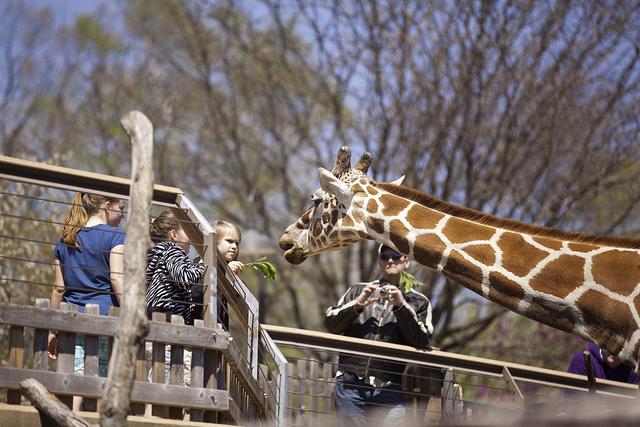Is this a scene from a third world country?
Write a very short answer. No. What is it eating?
Short answer required. Leaves. What is this animal?
Answer briefly. Giraffe. How many spots does the giraffe have showing?
Concise answer only. More than 15. How many giraffes are in the picture?
Quick response, please. 1. 